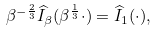Convert formula to latex. <formula><loc_0><loc_0><loc_500><loc_500>\beta ^ { - \frac { 2 } { 3 } } \widehat { I } _ { \beta } ( \beta ^ { \frac { 1 } { 3 } } \cdot ) = \widehat { I } _ { 1 } ( \cdot ) ,</formula> 